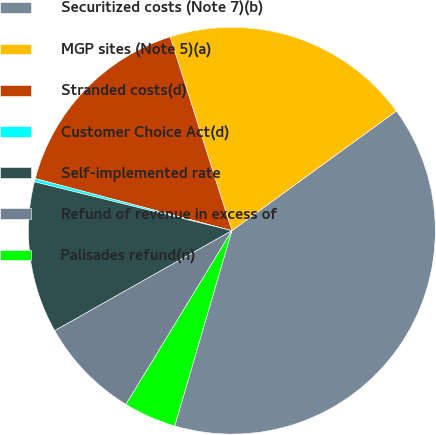Convert chart to OTSL. <chart><loc_0><loc_0><loc_500><loc_500><pie_chart><fcel>Securitized costs (Note 7)(b)<fcel>MGP sites (Note 5)(a)<fcel>Stranded costs(d)<fcel>Customer Choice Act(d)<fcel>Self-implemented rate<fcel>Refund of revenue in excess of<fcel>Palisades refund(n)<nl><fcel>39.54%<fcel>19.9%<fcel>15.97%<fcel>0.26%<fcel>12.04%<fcel>8.11%<fcel>4.18%<nl></chart> 